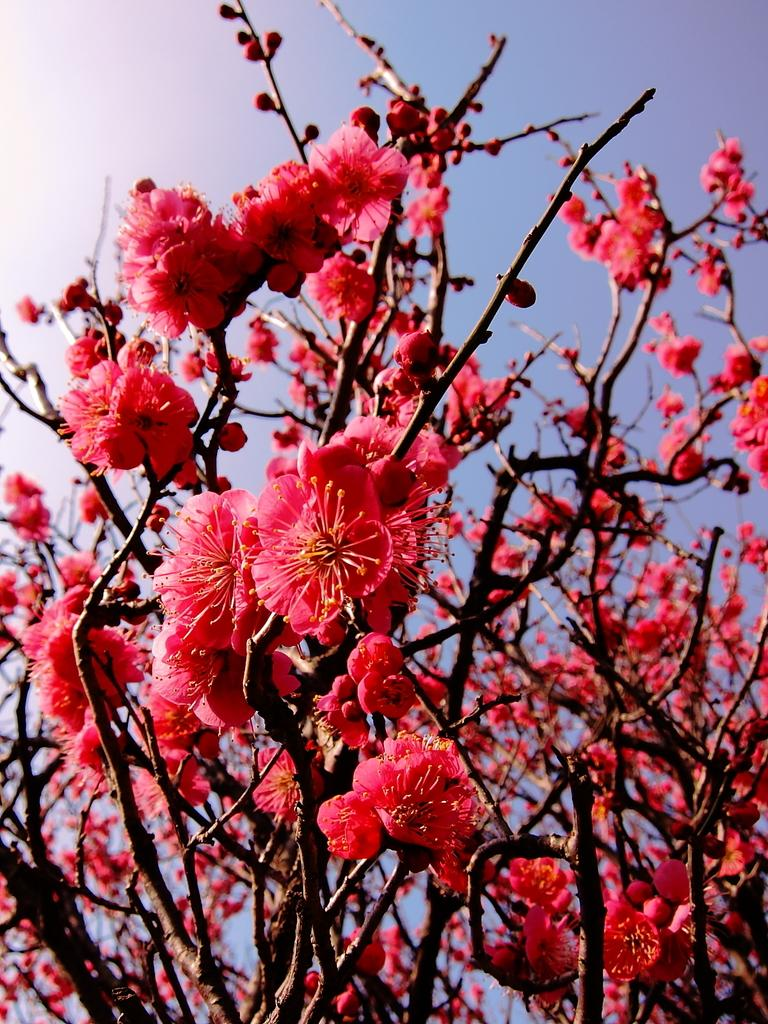What type of plants can be seen in the image? There are flowers in the image. What color is the background of the image? The background of the image is blue. How much waste is visible in the image? There is no waste visible in the image; it features flowers and a blue background. What is the name of the son in the image? There is no son present in the image. 